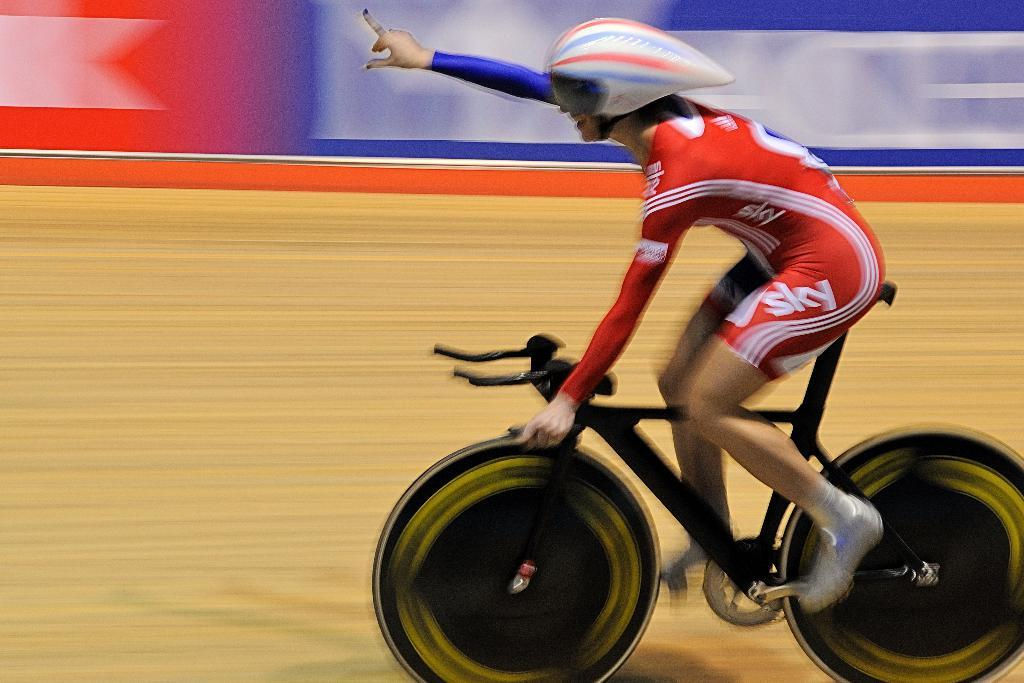<image>
Describe the image concisely. A woman in a red, cyclist uniform that says sky on the leg, is holding one hand up in the air as she rides her bicycle. 